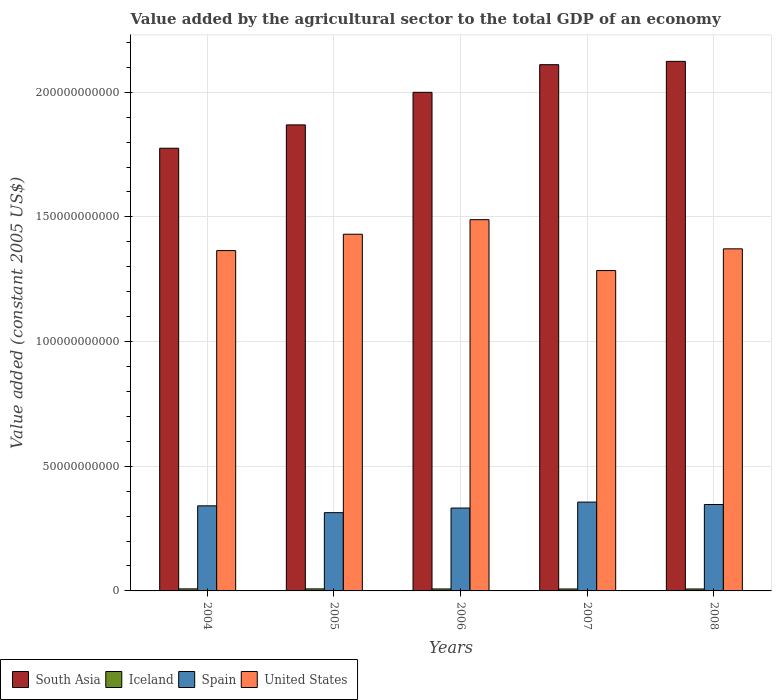How many different coloured bars are there?
Your answer should be compact. 4. How many groups of bars are there?
Give a very brief answer. 5. Are the number of bars per tick equal to the number of legend labels?
Offer a very short reply. Yes. Are the number of bars on each tick of the X-axis equal?
Keep it short and to the point. Yes. How many bars are there on the 5th tick from the right?
Keep it short and to the point. 4. In how many cases, is the number of bars for a given year not equal to the number of legend labels?
Ensure brevity in your answer.  0. What is the value added by the agricultural sector in United States in 2007?
Offer a terse response. 1.28e+11. Across all years, what is the maximum value added by the agricultural sector in Iceland?
Make the answer very short. 8.17e+08. Across all years, what is the minimum value added by the agricultural sector in South Asia?
Offer a terse response. 1.78e+11. In which year was the value added by the agricultural sector in Iceland maximum?
Your response must be concise. 2004. In which year was the value added by the agricultural sector in Iceland minimum?
Provide a short and direct response. 2007. What is the total value added by the agricultural sector in South Asia in the graph?
Give a very brief answer. 9.88e+11. What is the difference between the value added by the agricultural sector in Spain in 2006 and that in 2007?
Make the answer very short. -2.38e+09. What is the difference between the value added by the agricultural sector in United States in 2008 and the value added by the agricultural sector in Spain in 2004?
Ensure brevity in your answer.  1.03e+11. What is the average value added by the agricultural sector in United States per year?
Offer a terse response. 1.39e+11. In the year 2007, what is the difference between the value added by the agricultural sector in Iceland and value added by the agricultural sector in Spain?
Make the answer very short. -3.48e+1. In how many years, is the value added by the agricultural sector in United States greater than 180000000000 US$?
Your answer should be compact. 0. What is the ratio of the value added by the agricultural sector in Iceland in 2004 to that in 2008?
Provide a short and direct response. 1.05. Is the difference between the value added by the agricultural sector in Iceland in 2006 and 2007 greater than the difference between the value added by the agricultural sector in Spain in 2006 and 2007?
Your answer should be very brief. Yes. What is the difference between the highest and the second highest value added by the agricultural sector in South Asia?
Your response must be concise. 1.33e+09. What is the difference between the highest and the lowest value added by the agricultural sector in South Asia?
Your answer should be very brief. 3.48e+1. In how many years, is the value added by the agricultural sector in Iceland greater than the average value added by the agricultural sector in Iceland taken over all years?
Your answer should be very brief. 2. Is the sum of the value added by the agricultural sector in Spain in 2005 and 2008 greater than the maximum value added by the agricultural sector in South Asia across all years?
Keep it short and to the point. No. What does the 1st bar from the left in 2005 represents?
Give a very brief answer. South Asia. Is it the case that in every year, the sum of the value added by the agricultural sector in South Asia and value added by the agricultural sector in Iceland is greater than the value added by the agricultural sector in United States?
Ensure brevity in your answer.  Yes. How many bars are there?
Provide a succinct answer. 20. Are all the bars in the graph horizontal?
Give a very brief answer. No. Does the graph contain any zero values?
Provide a succinct answer. No. Does the graph contain grids?
Keep it short and to the point. Yes. How many legend labels are there?
Your answer should be very brief. 4. What is the title of the graph?
Your answer should be compact. Value added by the agricultural sector to the total GDP of an economy. Does "Sudan" appear as one of the legend labels in the graph?
Make the answer very short. No. What is the label or title of the Y-axis?
Give a very brief answer. Value added (constant 2005 US$). What is the Value added (constant 2005 US$) of South Asia in 2004?
Offer a very short reply. 1.78e+11. What is the Value added (constant 2005 US$) of Iceland in 2004?
Provide a short and direct response. 8.17e+08. What is the Value added (constant 2005 US$) of Spain in 2004?
Provide a succinct answer. 3.41e+1. What is the Value added (constant 2005 US$) in United States in 2004?
Make the answer very short. 1.36e+11. What is the Value added (constant 2005 US$) in South Asia in 2005?
Offer a terse response. 1.87e+11. What is the Value added (constant 2005 US$) of Iceland in 2005?
Make the answer very short. 8.11e+08. What is the Value added (constant 2005 US$) of Spain in 2005?
Provide a short and direct response. 3.14e+1. What is the Value added (constant 2005 US$) of United States in 2005?
Offer a terse response. 1.43e+11. What is the Value added (constant 2005 US$) of South Asia in 2006?
Your response must be concise. 2.00e+11. What is the Value added (constant 2005 US$) of Iceland in 2006?
Keep it short and to the point. 7.88e+08. What is the Value added (constant 2005 US$) of Spain in 2006?
Provide a succinct answer. 3.32e+1. What is the Value added (constant 2005 US$) in United States in 2006?
Keep it short and to the point. 1.49e+11. What is the Value added (constant 2005 US$) in South Asia in 2007?
Your answer should be very brief. 2.11e+11. What is the Value added (constant 2005 US$) of Iceland in 2007?
Your answer should be very brief. 7.77e+08. What is the Value added (constant 2005 US$) in Spain in 2007?
Offer a very short reply. 3.56e+1. What is the Value added (constant 2005 US$) in United States in 2007?
Offer a terse response. 1.28e+11. What is the Value added (constant 2005 US$) in South Asia in 2008?
Your response must be concise. 2.12e+11. What is the Value added (constant 2005 US$) in Iceland in 2008?
Ensure brevity in your answer.  7.77e+08. What is the Value added (constant 2005 US$) in Spain in 2008?
Your answer should be very brief. 3.47e+1. What is the Value added (constant 2005 US$) of United States in 2008?
Offer a very short reply. 1.37e+11. Across all years, what is the maximum Value added (constant 2005 US$) of South Asia?
Your answer should be compact. 2.12e+11. Across all years, what is the maximum Value added (constant 2005 US$) of Iceland?
Make the answer very short. 8.17e+08. Across all years, what is the maximum Value added (constant 2005 US$) in Spain?
Your response must be concise. 3.56e+1. Across all years, what is the maximum Value added (constant 2005 US$) of United States?
Your response must be concise. 1.49e+11. Across all years, what is the minimum Value added (constant 2005 US$) of South Asia?
Your answer should be very brief. 1.78e+11. Across all years, what is the minimum Value added (constant 2005 US$) of Iceland?
Your answer should be compact. 7.77e+08. Across all years, what is the minimum Value added (constant 2005 US$) in Spain?
Offer a terse response. 3.14e+1. Across all years, what is the minimum Value added (constant 2005 US$) in United States?
Offer a very short reply. 1.28e+11. What is the total Value added (constant 2005 US$) of South Asia in the graph?
Provide a short and direct response. 9.88e+11. What is the total Value added (constant 2005 US$) in Iceland in the graph?
Provide a succinct answer. 3.97e+09. What is the total Value added (constant 2005 US$) in Spain in the graph?
Ensure brevity in your answer.  1.69e+11. What is the total Value added (constant 2005 US$) in United States in the graph?
Your answer should be very brief. 6.94e+11. What is the difference between the Value added (constant 2005 US$) of South Asia in 2004 and that in 2005?
Keep it short and to the point. -9.37e+09. What is the difference between the Value added (constant 2005 US$) in Iceland in 2004 and that in 2005?
Your response must be concise. 5.69e+06. What is the difference between the Value added (constant 2005 US$) in Spain in 2004 and that in 2005?
Give a very brief answer. 2.74e+09. What is the difference between the Value added (constant 2005 US$) in United States in 2004 and that in 2005?
Offer a very short reply. -6.56e+09. What is the difference between the Value added (constant 2005 US$) in South Asia in 2004 and that in 2006?
Your response must be concise. -2.24e+1. What is the difference between the Value added (constant 2005 US$) of Iceland in 2004 and that in 2006?
Provide a short and direct response. 2.92e+07. What is the difference between the Value added (constant 2005 US$) of Spain in 2004 and that in 2006?
Your answer should be compact. 8.82e+08. What is the difference between the Value added (constant 2005 US$) in United States in 2004 and that in 2006?
Your answer should be compact. -1.24e+1. What is the difference between the Value added (constant 2005 US$) of South Asia in 2004 and that in 2007?
Keep it short and to the point. -3.35e+1. What is the difference between the Value added (constant 2005 US$) in Iceland in 2004 and that in 2007?
Keep it short and to the point. 4.04e+07. What is the difference between the Value added (constant 2005 US$) of Spain in 2004 and that in 2007?
Provide a short and direct response. -1.50e+09. What is the difference between the Value added (constant 2005 US$) in United States in 2004 and that in 2007?
Offer a very short reply. 8.02e+09. What is the difference between the Value added (constant 2005 US$) in South Asia in 2004 and that in 2008?
Provide a short and direct response. -3.48e+1. What is the difference between the Value added (constant 2005 US$) in Iceland in 2004 and that in 2008?
Your answer should be compact. 3.94e+07. What is the difference between the Value added (constant 2005 US$) in Spain in 2004 and that in 2008?
Make the answer very short. -5.31e+08. What is the difference between the Value added (constant 2005 US$) in United States in 2004 and that in 2008?
Keep it short and to the point. -7.02e+08. What is the difference between the Value added (constant 2005 US$) of South Asia in 2005 and that in 2006?
Provide a short and direct response. -1.31e+1. What is the difference between the Value added (constant 2005 US$) in Iceland in 2005 and that in 2006?
Your answer should be compact. 2.35e+07. What is the difference between the Value added (constant 2005 US$) of Spain in 2005 and that in 2006?
Provide a succinct answer. -1.86e+09. What is the difference between the Value added (constant 2005 US$) of United States in 2005 and that in 2006?
Make the answer very short. -5.84e+09. What is the difference between the Value added (constant 2005 US$) of South Asia in 2005 and that in 2007?
Give a very brief answer. -2.41e+1. What is the difference between the Value added (constant 2005 US$) of Iceland in 2005 and that in 2007?
Offer a terse response. 3.47e+07. What is the difference between the Value added (constant 2005 US$) of Spain in 2005 and that in 2007?
Ensure brevity in your answer.  -4.24e+09. What is the difference between the Value added (constant 2005 US$) in United States in 2005 and that in 2007?
Offer a terse response. 1.46e+1. What is the difference between the Value added (constant 2005 US$) of South Asia in 2005 and that in 2008?
Offer a terse response. -2.55e+1. What is the difference between the Value added (constant 2005 US$) of Iceland in 2005 and that in 2008?
Your answer should be very brief. 3.37e+07. What is the difference between the Value added (constant 2005 US$) of Spain in 2005 and that in 2008?
Provide a short and direct response. -3.27e+09. What is the difference between the Value added (constant 2005 US$) of United States in 2005 and that in 2008?
Ensure brevity in your answer.  5.86e+09. What is the difference between the Value added (constant 2005 US$) of South Asia in 2006 and that in 2007?
Offer a very short reply. -1.11e+1. What is the difference between the Value added (constant 2005 US$) of Iceland in 2006 and that in 2007?
Keep it short and to the point. 1.12e+07. What is the difference between the Value added (constant 2005 US$) in Spain in 2006 and that in 2007?
Your answer should be compact. -2.38e+09. What is the difference between the Value added (constant 2005 US$) of United States in 2006 and that in 2007?
Keep it short and to the point. 2.04e+1. What is the difference between the Value added (constant 2005 US$) in South Asia in 2006 and that in 2008?
Offer a very short reply. -1.24e+1. What is the difference between the Value added (constant 2005 US$) in Iceland in 2006 and that in 2008?
Offer a very short reply. 1.03e+07. What is the difference between the Value added (constant 2005 US$) in Spain in 2006 and that in 2008?
Give a very brief answer. -1.41e+09. What is the difference between the Value added (constant 2005 US$) of United States in 2006 and that in 2008?
Ensure brevity in your answer.  1.17e+1. What is the difference between the Value added (constant 2005 US$) in South Asia in 2007 and that in 2008?
Ensure brevity in your answer.  -1.33e+09. What is the difference between the Value added (constant 2005 US$) of Iceland in 2007 and that in 2008?
Offer a terse response. -9.22e+05. What is the difference between the Value added (constant 2005 US$) of Spain in 2007 and that in 2008?
Keep it short and to the point. 9.66e+08. What is the difference between the Value added (constant 2005 US$) in United States in 2007 and that in 2008?
Your answer should be compact. -8.72e+09. What is the difference between the Value added (constant 2005 US$) in South Asia in 2004 and the Value added (constant 2005 US$) in Iceland in 2005?
Give a very brief answer. 1.77e+11. What is the difference between the Value added (constant 2005 US$) in South Asia in 2004 and the Value added (constant 2005 US$) in Spain in 2005?
Provide a short and direct response. 1.46e+11. What is the difference between the Value added (constant 2005 US$) in South Asia in 2004 and the Value added (constant 2005 US$) in United States in 2005?
Keep it short and to the point. 3.45e+1. What is the difference between the Value added (constant 2005 US$) in Iceland in 2004 and the Value added (constant 2005 US$) in Spain in 2005?
Offer a terse response. -3.06e+1. What is the difference between the Value added (constant 2005 US$) of Iceland in 2004 and the Value added (constant 2005 US$) of United States in 2005?
Your response must be concise. -1.42e+11. What is the difference between the Value added (constant 2005 US$) in Spain in 2004 and the Value added (constant 2005 US$) in United States in 2005?
Offer a very short reply. -1.09e+11. What is the difference between the Value added (constant 2005 US$) in South Asia in 2004 and the Value added (constant 2005 US$) in Iceland in 2006?
Offer a terse response. 1.77e+11. What is the difference between the Value added (constant 2005 US$) of South Asia in 2004 and the Value added (constant 2005 US$) of Spain in 2006?
Your answer should be very brief. 1.44e+11. What is the difference between the Value added (constant 2005 US$) in South Asia in 2004 and the Value added (constant 2005 US$) in United States in 2006?
Provide a short and direct response. 2.86e+1. What is the difference between the Value added (constant 2005 US$) of Iceland in 2004 and the Value added (constant 2005 US$) of Spain in 2006?
Provide a succinct answer. -3.24e+1. What is the difference between the Value added (constant 2005 US$) of Iceland in 2004 and the Value added (constant 2005 US$) of United States in 2006?
Keep it short and to the point. -1.48e+11. What is the difference between the Value added (constant 2005 US$) in Spain in 2004 and the Value added (constant 2005 US$) in United States in 2006?
Provide a short and direct response. -1.15e+11. What is the difference between the Value added (constant 2005 US$) of South Asia in 2004 and the Value added (constant 2005 US$) of Iceland in 2007?
Your answer should be compact. 1.77e+11. What is the difference between the Value added (constant 2005 US$) in South Asia in 2004 and the Value added (constant 2005 US$) in Spain in 2007?
Keep it short and to the point. 1.42e+11. What is the difference between the Value added (constant 2005 US$) in South Asia in 2004 and the Value added (constant 2005 US$) in United States in 2007?
Give a very brief answer. 4.91e+1. What is the difference between the Value added (constant 2005 US$) in Iceland in 2004 and the Value added (constant 2005 US$) in Spain in 2007?
Ensure brevity in your answer.  -3.48e+1. What is the difference between the Value added (constant 2005 US$) of Iceland in 2004 and the Value added (constant 2005 US$) of United States in 2007?
Provide a succinct answer. -1.28e+11. What is the difference between the Value added (constant 2005 US$) of Spain in 2004 and the Value added (constant 2005 US$) of United States in 2007?
Make the answer very short. -9.44e+1. What is the difference between the Value added (constant 2005 US$) in South Asia in 2004 and the Value added (constant 2005 US$) in Iceland in 2008?
Your answer should be compact. 1.77e+11. What is the difference between the Value added (constant 2005 US$) of South Asia in 2004 and the Value added (constant 2005 US$) of Spain in 2008?
Provide a succinct answer. 1.43e+11. What is the difference between the Value added (constant 2005 US$) in South Asia in 2004 and the Value added (constant 2005 US$) in United States in 2008?
Your answer should be compact. 4.03e+1. What is the difference between the Value added (constant 2005 US$) in Iceland in 2004 and the Value added (constant 2005 US$) in Spain in 2008?
Make the answer very short. -3.38e+1. What is the difference between the Value added (constant 2005 US$) in Iceland in 2004 and the Value added (constant 2005 US$) in United States in 2008?
Provide a succinct answer. -1.36e+11. What is the difference between the Value added (constant 2005 US$) in Spain in 2004 and the Value added (constant 2005 US$) in United States in 2008?
Your response must be concise. -1.03e+11. What is the difference between the Value added (constant 2005 US$) in South Asia in 2005 and the Value added (constant 2005 US$) in Iceland in 2006?
Your answer should be compact. 1.86e+11. What is the difference between the Value added (constant 2005 US$) in South Asia in 2005 and the Value added (constant 2005 US$) in Spain in 2006?
Ensure brevity in your answer.  1.54e+11. What is the difference between the Value added (constant 2005 US$) of South Asia in 2005 and the Value added (constant 2005 US$) of United States in 2006?
Your answer should be very brief. 3.80e+1. What is the difference between the Value added (constant 2005 US$) of Iceland in 2005 and the Value added (constant 2005 US$) of Spain in 2006?
Keep it short and to the point. -3.24e+1. What is the difference between the Value added (constant 2005 US$) of Iceland in 2005 and the Value added (constant 2005 US$) of United States in 2006?
Provide a short and direct response. -1.48e+11. What is the difference between the Value added (constant 2005 US$) in Spain in 2005 and the Value added (constant 2005 US$) in United States in 2006?
Your answer should be compact. -1.18e+11. What is the difference between the Value added (constant 2005 US$) in South Asia in 2005 and the Value added (constant 2005 US$) in Iceland in 2007?
Provide a succinct answer. 1.86e+11. What is the difference between the Value added (constant 2005 US$) of South Asia in 2005 and the Value added (constant 2005 US$) of Spain in 2007?
Provide a short and direct response. 1.51e+11. What is the difference between the Value added (constant 2005 US$) of South Asia in 2005 and the Value added (constant 2005 US$) of United States in 2007?
Make the answer very short. 5.84e+1. What is the difference between the Value added (constant 2005 US$) in Iceland in 2005 and the Value added (constant 2005 US$) in Spain in 2007?
Ensure brevity in your answer.  -3.48e+1. What is the difference between the Value added (constant 2005 US$) in Iceland in 2005 and the Value added (constant 2005 US$) in United States in 2007?
Keep it short and to the point. -1.28e+11. What is the difference between the Value added (constant 2005 US$) in Spain in 2005 and the Value added (constant 2005 US$) in United States in 2007?
Offer a terse response. -9.71e+1. What is the difference between the Value added (constant 2005 US$) in South Asia in 2005 and the Value added (constant 2005 US$) in Iceland in 2008?
Provide a short and direct response. 1.86e+11. What is the difference between the Value added (constant 2005 US$) in South Asia in 2005 and the Value added (constant 2005 US$) in Spain in 2008?
Your answer should be very brief. 1.52e+11. What is the difference between the Value added (constant 2005 US$) in South Asia in 2005 and the Value added (constant 2005 US$) in United States in 2008?
Your answer should be very brief. 4.97e+1. What is the difference between the Value added (constant 2005 US$) of Iceland in 2005 and the Value added (constant 2005 US$) of Spain in 2008?
Offer a very short reply. -3.38e+1. What is the difference between the Value added (constant 2005 US$) in Iceland in 2005 and the Value added (constant 2005 US$) in United States in 2008?
Offer a terse response. -1.36e+11. What is the difference between the Value added (constant 2005 US$) in Spain in 2005 and the Value added (constant 2005 US$) in United States in 2008?
Make the answer very short. -1.06e+11. What is the difference between the Value added (constant 2005 US$) of South Asia in 2006 and the Value added (constant 2005 US$) of Iceland in 2007?
Provide a short and direct response. 1.99e+11. What is the difference between the Value added (constant 2005 US$) of South Asia in 2006 and the Value added (constant 2005 US$) of Spain in 2007?
Your answer should be compact. 1.64e+11. What is the difference between the Value added (constant 2005 US$) of South Asia in 2006 and the Value added (constant 2005 US$) of United States in 2007?
Provide a short and direct response. 7.15e+1. What is the difference between the Value added (constant 2005 US$) of Iceland in 2006 and the Value added (constant 2005 US$) of Spain in 2007?
Provide a short and direct response. -3.48e+1. What is the difference between the Value added (constant 2005 US$) of Iceland in 2006 and the Value added (constant 2005 US$) of United States in 2007?
Offer a terse response. -1.28e+11. What is the difference between the Value added (constant 2005 US$) of Spain in 2006 and the Value added (constant 2005 US$) of United States in 2007?
Your answer should be compact. -9.52e+1. What is the difference between the Value added (constant 2005 US$) in South Asia in 2006 and the Value added (constant 2005 US$) in Iceland in 2008?
Keep it short and to the point. 1.99e+11. What is the difference between the Value added (constant 2005 US$) in South Asia in 2006 and the Value added (constant 2005 US$) in Spain in 2008?
Provide a succinct answer. 1.65e+11. What is the difference between the Value added (constant 2005 US$) in South Asia in 2006 and the Value added (constant 2005 US$) in United States in 2008?
Your answer should be very brief. 6.28e+1. What is the difference between the Value added (constant 2005 US$) in Iceland in 2006 and the Value added (constant 2005 US$) in Spain in 2008?
Provide a short and direct response. -3.39e+1. What is the difference between the Value added (constant 2005 US$) in Iceland in 2006 and the Value added (constant 2005 US$) in United States in 2008?
Your answer should be compact. -1.36e+11. What is the difference between the Value added (constant 2005 US$) of Spain in 2006 and the Value added (constant 2005 US$) of United States in 2008?
Your answer should be very brief. -1.04e+11. What is the difference between the Value added (constant 2005 US$) in South Asia in 2007 and the Value added (constant 2005 US$) in Iceland in 2008?
Your answer should be very brief. 2.10e+11. What is the difference between the Value added (constant 2005 US$) of South Asia in 2007 and the Value added (constant 2005 US$) of Spain in 2008?
Make the answer very short. 1.76e+11. What is the difference between the Value added (constant 2005 US$) in South Asia in 2007 and the Value added (constant 2005 US$) in United States in 2008?
Provide a succinct answer. 7.39e+1. What is the difference between the Value added (constant 2005 US$) of Iceland in 2007 and the Value added (constant 2005 US$) of Spain in 2008?
Offer a terse response. -3.39e+1. What is the difference between the Value added (constant 2005 US$) of Iceland in 2007 and the Value added (constant 2005 US$) of United States in 2008?
Ensure brevity in your answer.  -1.36e+11. What is the difference between the Value added (constant 2005 US$) in Spain in 2007 and the Value added (constant 2005 US$) in United States in 2008?
Your answer should be compact. -1.02e+11. What is the average Value added (constant 2005 US$) of South Asia per year?
Your response must be concise. 1.98e+11. What is the average Value added (constant 2005 US$) of Iceland per year?
Make the answer very short. 7.94e+08. What is the average Value added (constant 2005 US$) of Spain per year?
Offer a very short reply. 3.38e+1. What is the average Value added (constant 2005 US$) of United States per year?
Your response must be concise. 1.39e+11. In the year 2004, what is the difference between the Value added (constant 2005 US$) in South Asia and Value added (constant 2005 US$) in Iceland?
Offer a very short reply. 1.77e+11. In the year 2004, what is the difference between the Value added (constant 2005 US$) of South Asia and Value added (constant 2005 US$) of Spain?
Offer a very short reply. 1.43e+11. In the year 2004, what is the difference between the Value added (constant 2005 US$) of South Asia and Value added (constant 2005 US$) of United States?
Offer a very short reply. 4.10e+1. In the year 2004, what is the difference between the Value added (constant 2005 US$) in Iceland and Value added (constant 2005 US$) in Spain?
Offer a terse response. -3.33e+1. In the year 2004, what is the difference between the Value added (constant 2005 US$) in Iceland and Value added (constant 2005 US$) in United States?
Provide a short and direct response. -1.36e+11. In the year 2004, what is the difference between the Value added (constant 2005 US$) in Spain and Value added (constant 2005 US$) in United States?
Your response must be concise. -1.02e+11. In the year 2005, what is the difference between the Value added (constant 2005 US$) of South Asia and Value added (constant 2005 US$) of Iceland?
Make the answer very short. 1.86e+11. In the year 2005, what is the difference between the Value added (constant 2005 US$) in South Asia and Value added (constant 2005 US$) in Spain?
Ensure brevity in your answer.  1.56e+11. In the year 2005, what is the difference between the Value added (constant 2005 US$) of South Asia and Value added (constant 2005 US$) of United States?
Ensure brevity in your answer.  4.39e+1. In the year 2005, what is the difference between the Value added (constant 2005 US$) of Iceland and Value added (constant 2005 US$) of Spain?
Keep it short and to the point. -3.06e+1. In the year 2005, what is the difference between the Value added (constant 2005 US$) of Iceland and Value added (constant 2005 US$) of United States?
Provide a short and direct response. -1.42e+11. In the year 2005, what is the difference between the Value added (constant 2005 US$) of Spain and Value added (constant 2005 US$) of United States?
Ensure brevity in your answer.  -1.12e+11. In the year 2006, what is the difference between the Value added (constant 2005 US$) of South Asia and Value added (constant 2005 US$) of Iceland?
Give a very brief answer. 1.99e+11. In the year 2006, what is the difference between the Value added (constant 2005 US$) in South Asia and Value added (constant 2005 US$) in Spain?
Keep it short and to the point. 1.67e+11. In the year 2006, what is the difference between the Value added (constant 2005 US$) in South Asia and Value added (constant 2005 US$) in United States?
Provide a succinct answer. 5.11e+1. In the year 2006, what is the difference between the Value added (constant 2005 US$) in Iceland and Value added (constant 2005 US$) in Spain?
Provide a succinct answer. -3.25e+1. In the year 2006, what is the difference between the Value added (constant 2005 US$) in Iceland and Value added (constant 2005 US$) in United States?
Your response must be concise. -1.48e+11. In the year 2006, what is the difference between the Value added (constant 2005 US$) of Spain and Value added (constant 2005 US$) of United States?
Your answer should be compact. -1.16e+11. In the year 2007, what is the difference between the Value added (constant 2005 US$) in South Asia and Value added (constant 2005 US$) in Iceland?
Provide a succinct answer. 2.10e+11. In the year 2007, what is the difference between the Value added (constant 2005 US$) of South Asia and Value added (constant 2005 US$) of Spain?
Your response must be concise. 1.75e+11. In the year 2007, what is the difference between the Value added (constant 2005 US$) in South Asia and Value added (constant 2005 US$) in United States?
Provide a short and direct response. 8.26e+1. In the year 2007, what is the difference between the Value added (constant 2005 US$) of Iceland and Value added (constant 2005 US$) of Spain?
Offer a terse response. -3.48e+1. In the year 2007, what is the difference between the Value added (constant 2005 US$) of Iceland and Value added (constant 2005 US$) of United States?
Your response must be concise. -1.28e+11. In the year 2007, what is the difference between the Value added (constant 2005 US$) of Spain and Value added (constant 2005 US$) of United States?
Provide a short and direct response. -9.29e+1. In the year 2008, what is the difference between the Value added (constant 2005 US$) of South Asia and Value added (constant 2005 US$) of Iceland?
Your response must be concise. 2.12e+11. In the year 2008, what is the difference between the Value added (constant 2005 US$) in South Asia and Value added (constant 2005 US$) in Spain?
Ensure brevity in your answer.  1.78e+11. In the year 2008, what is the difference between the Value added (constant 2005 US$) in South Asia and Value added (constant 2005 US$) in United States?
Offer a terse response. 7.52e+1. In the year 2008, what is the difference between the Value added (constant 2005 US$) of Iceland and Value added (constant 2005 US$) of Spain?
Keep it short and to the point. -3.39e+1. In the year 2008, what is the difference between the Value added (constant 2005 US$) of Iceland and Value added (constant 2005 US$) of United States?
Your response must be concise. -1.36e+11. In the year 2008, what is the difference between the Value added (constant 2005 US$) of Spain and Value added (constant 2005 US$) of United States?
Keep it short and to the point. -1.03e+11. What is the ratio of the Value added (constant 2005 US$) in South Asia in 2004 to that in 2005?
Keep it short and to the point. 0.95. What is the ratio of the Value added (constant 2005 US$) in Iceland in 2004 to that in 2005?
Your response must be concise. 1.01. What is the ratio of the Value added (constant 2005 US$) in Spain in 2004 to that in 2005?
Offer a terse response. 1.09. What is the ratio of the Value added (constant 2005 US$) in United States in 2004 to that in 2005?
Provide a succinct answer. 0.95. What is the ratio of the Value added (constant 2005 US$) in South Asia in 2004 to that in 2006?
Give a very brief answer. 0.89. What is the ratio of the Value added (constant 2005 US$) in Spain in 2004 to that in 2006?
Your answer should be compact. 1.03. What is the ratio of the Value added (constant 2005 US$) of United States in 2004 to that in 2006?
Your answer should be compact. 0.92. What is the ratio of the Value added (constant 2005 US$) in South Asia in 2004 to that in 2007?
Ensure brevity in your answer.  0.84. What is the ratio of the Value added (constant 2005 US$) of Iceland in 2004 to that in 2007?
Your answer should be compact. 1.05. What is the ratio of the Value added (constant 2005 US$) in Spain in 2004 to that in 2007?
Offer a terse response. 0.96. What is the ratio of the Value added (constant 2005 US$) of United States in 2004 to that in 2007?
Your response must be concise. 1.06. What is the ratio of the Value added (constant 2005 US$) in South Asia in 2004 to that in 2008?
Provide a succinct answer. 0.84. What is the ratio of the Value added (constant 2005 US$) of Iceland in 2004 to that in 2008?
Offer a very short reply. 1.05. What is the ratio of the Value added (constant 2005 US$) of Spain in 2004 to that in 2008?
Your response must be concise. 0.98. What is the ratio of the Value added (constant 2005 US$) in South Asia in 2005 to that in 2006?
Offer a very short reply. 0.93. What is the ratio of the Value added (constant 2005 US$) in Iceland in 2005 to that in 2006?
Make the answer very short. 1.03. What is the ratio of the Value added (constant 2005 US$) in Spain in 2005 to that in 2006?
Offer a very short reply. 0.94. What is the ratio of the Value added (constant 2005 US$) in United States in 2005 to that in 2006?
Your answer should be compact. 0.96. What is the ratio of the Value added (constant 2005 US$) in South Asia in 2005 to that in 2007?
Give a very brief answer. 0.89. What is the ratio of the Value added (constant 2005 US$) in Iceland in 2005 to that in 2007?
Make the answer very short. 1.04. What is the ratio of the Value added (constant 2005 US$) in Spain in 2005 to that in 2007?
Offer a very short reply. 0.88. What is the ratio of the Value added (constant 2005 US$) in United States in 2005 to that in 2007?
Your answer should be compact. 1.11. What is the ratio of the Value added (constant 2005 US$) in Iceland in 2005 to that in 2008?
Your response must be concise. 1.04. What is the ratio of the Value added (constant 2005 US$) in Spain in 2005 to that in 2008?
Your answer should be very brief. 0.91. What is the ratio of the Value added (constant 2005 US$) of United States in 2005 to that in 2008?
Give a very brief answer. 1.04. What is the ratio of the Value added (constant 2005 US$) of South Asia in 2006 to that in 2007?
Give a very brief answer. 0.95. What is the ratio of the Value added (constant 2005 US$) of Iceland in 2006 to that in 2007?
Your answer should be compact. 1.01. What is the ratio of the Value added (constant 2005 US$) in Spain in 2006 to that in 2007?
Offer a terse response. 0.93. What is the ratio of the Value added (constant 2005 US$) in United States in 2006 to that in 2007?
Your answer should be compact. 1.16. What is the ratio of the Value added (constant 2005 US$) of South Asia in 2006 to that in 2008?
Make the answer very short. 0.94. What is the ratio of the Value added (constant 2005 US$) in Iceland in 2006 to that in 2008?
Your response must be concise. 1.01. What is the ratio of the Value added (constant 2005 US$) of Spain in 2006 to that in 2008?
Offer a terse response. 0.96. What is the ratio of the Value added (constant 2005 US$) of United States in 2006 to that in 2008?
Give a very brief answer. 1.09. What is the ratio of the Value added (constant 2005 US$) of South Asia in 2007 to that in 2008?
Give a very brief answer. 0.99. What is the ratio of the Value added (constant 2005 US$) in Iceland in 2007 to that in 2008?
Your answer should be very brief. 1. What is the ratio of the Value added (constant 2005 US$) in Spain in 2007 to that in 2008?
Provide a succinct answer. 1.03. What is the ratio of the Value added (constant 2005 US$) in United States in 2007 to that in 2008?
Your answer should be very brief. 0.94. What is the difference between the highest and the second highest Value added (constant 2005 US$) of South Asia?
Give a very brief answer. 1.33e+09. What is the difference between the highest and the second highest Value added (constant 2005 US$) of Iceland?
Ensure brevity in your answer.  5.69e+06. What is the difference between the highest and the second highest Value added (constant 2005 US$) in Spain?
Offer a very short reply. 9.66e+08. What is the difference between the highest and the second highest Value added (constant 2005 US$) of United States?
Your answer should be compact. 5.84e+09. What is the difference between the highest and the lowest Value added (constant 2005 US$) of South Asia?
Give a very brief answer. 3.48e+1. What is the difference between the highest and the lowest Value added (constant 2005 US$) of Iceland?
Give a very brief answer. 4.04e+07. What is the difference between the highest and the lowest Value added (constant 2005 US$) of Spain?
Provide a succinct answer. 4.24e+09. What is the difference between the highest and the lowest Value added (constant 2005 US$) of United States?
Provide a short and direct response. 2.04e+1. 